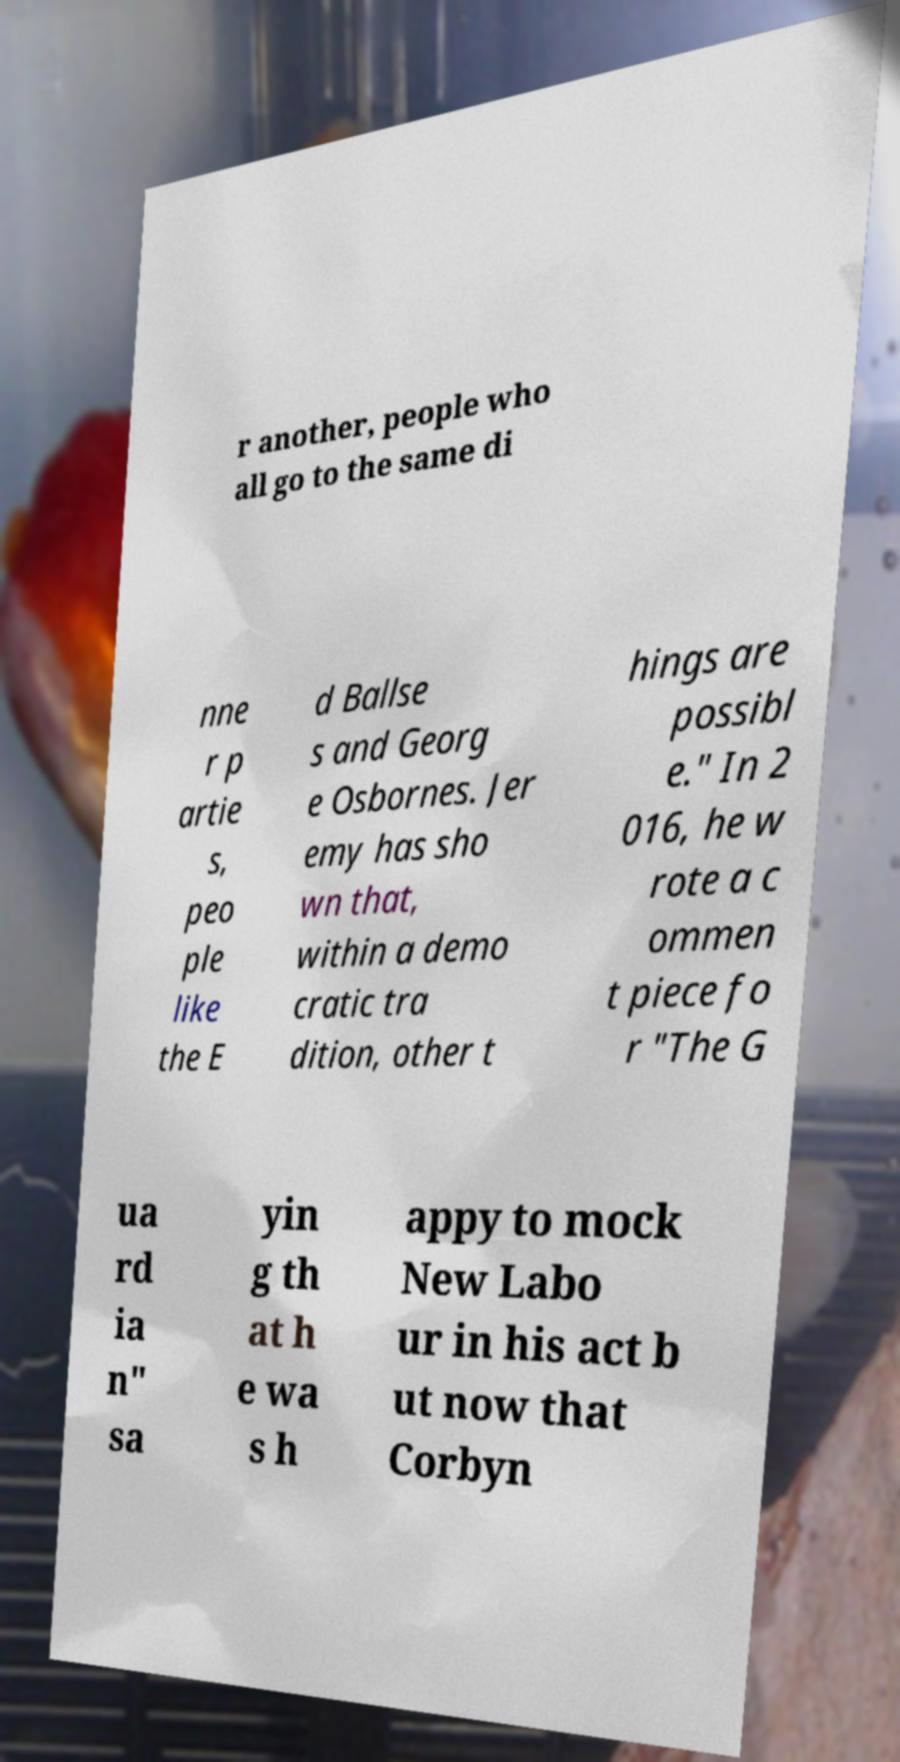Can you read and provide the text displayed in the image?This photo seems to have some interesting text. Can you extract and type it out for me? r another, people who all go to the same di nne r p artie s, peo ple like the E d Ballse s and Georg e Osbornes. Jer emy has sho wn that, within a demo cratic tra dition, other t hings are possibl e." In 2 016, he w rote a c ommen t piece fo r "The G ua rd ia n" sa yin g th at h e wa s h appy to mock New Labo ur in his act b ut now that Corbyn 